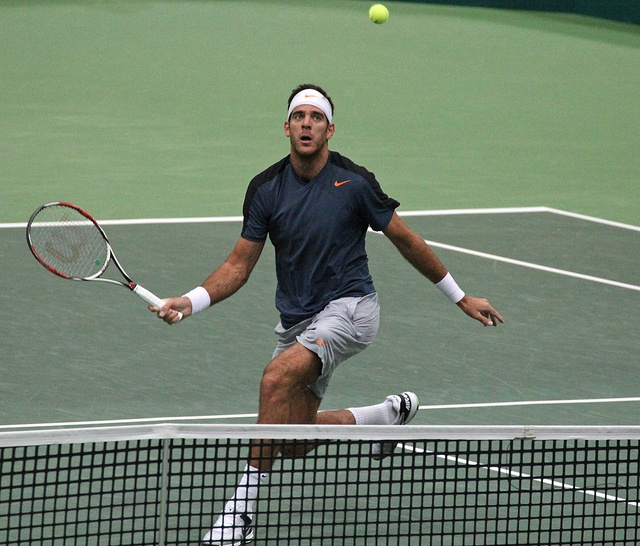Describe the objects in this image and their specific colors. I can see people in green, black, brown, gray, and darkgray tones, tennis racket in green, gray, darkgray, and lightgray tones, and sports ball in green, khaki, and lightgreen tones in this image. 